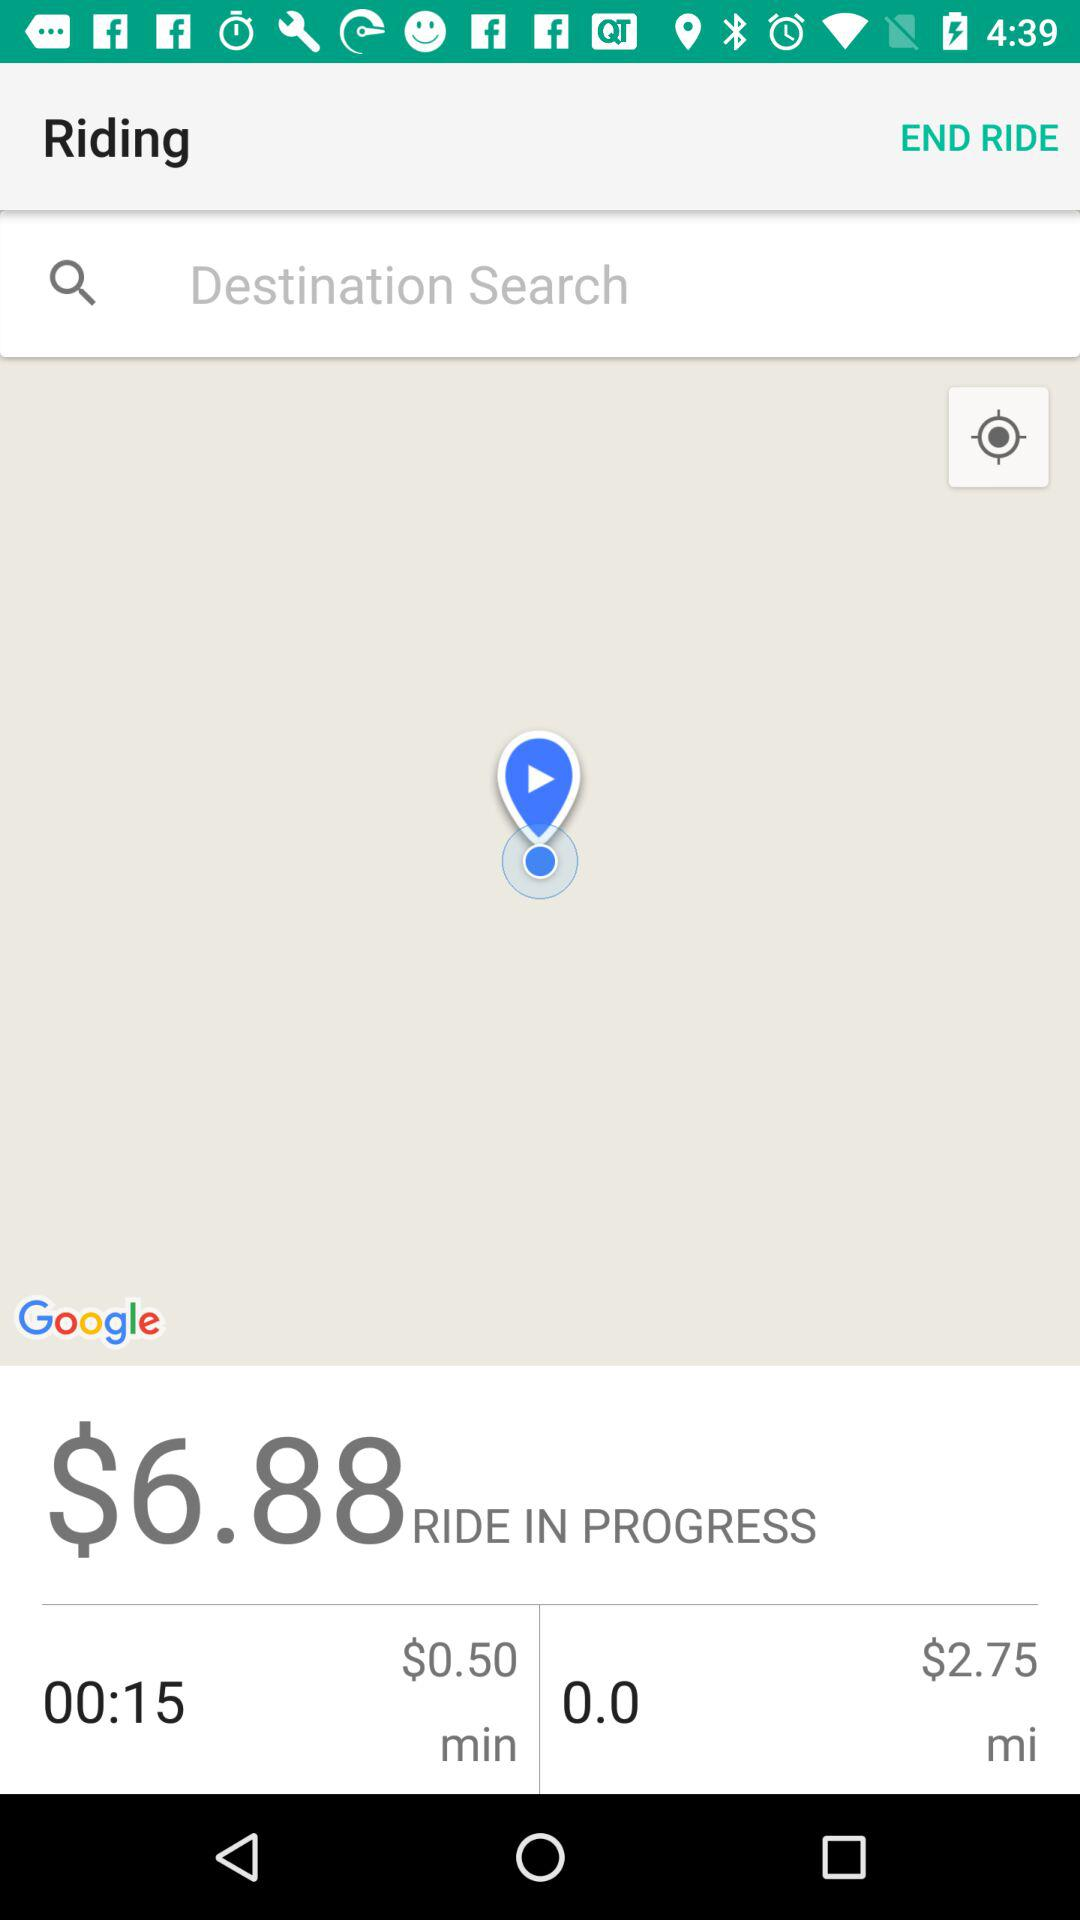How much longer will the ride take?
Answer the question using a single word or phrase. 00:15 